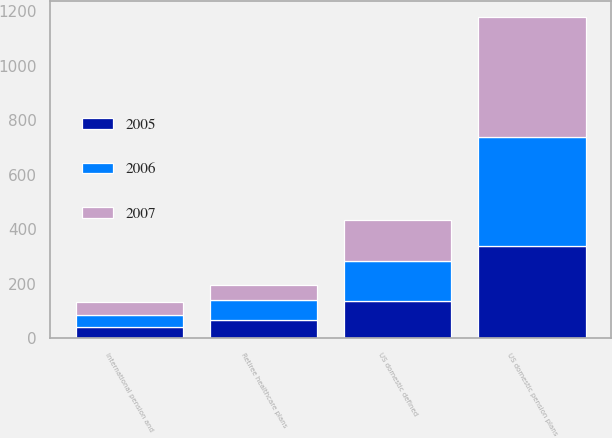<chart> <loc_0><loc_0><loc_500><loc_500><stacked_bar_chart><ecel><fcel>US domestic pension plans<fcel>International pension and<fcel>US domestic defined<fcel>Retiree healthcare plans<nl><fcel>2007<fcel>442<fcel>49<fcel>152<fcel>55<nl><fcel>2006<fcel>400<fcel>45<fcel>147<fcel>73<nl><fcel>2005<fcel>337<fcel>41<fcel>136<fcel>68<nl></chart> 